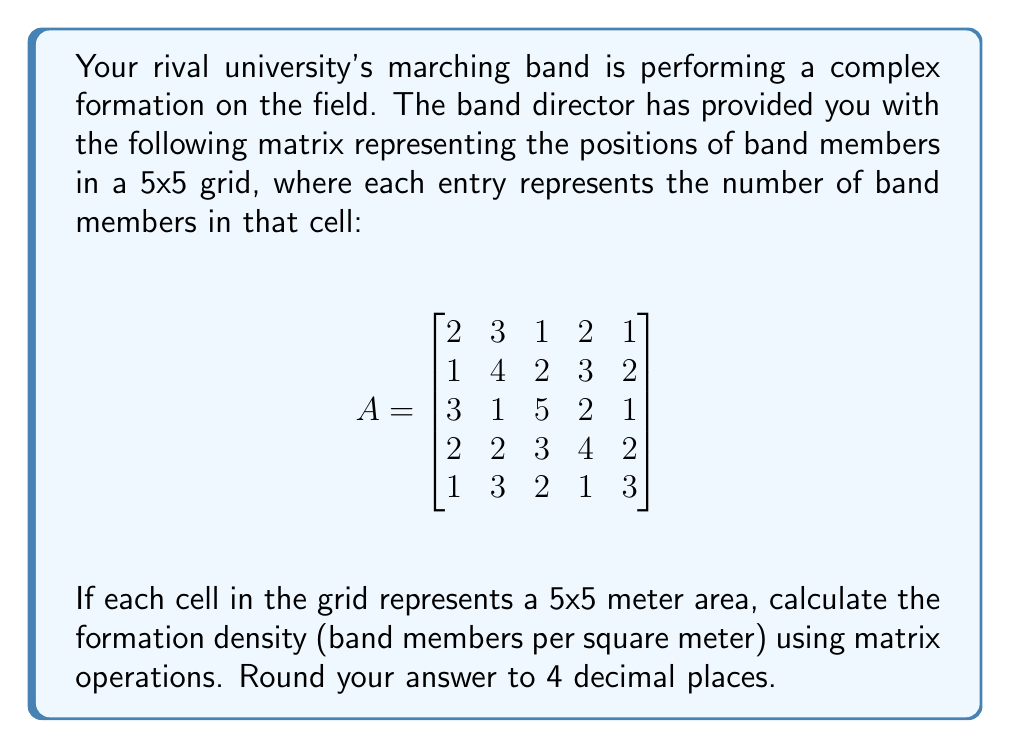Can you answer this question? To solve this problem, we'll follow these steps:

1) First, we need to calculate the total number of band members. We can do this by summing all elements in the matrix. In matrix notation, this is equivalent to multiplying the matrix by a column vector of ones and then multiplying the result by a row vector of ones:

   $$\text{Total members} = \mathbf{1}^T A \mathbf{1}$$

   Where $\mathbf{1}$ is a 5x1 column vector of ones, and $\mathbf{1}^T$ is its transpose.

2) Let's perform this calculation:

   $$\begin{bmatrix}1 & 1 & 1 & 1 & 1\end{bmatrix} \begin{bmatrix}
   2 & 3 & 1 & 2 & 1 \\
   1 & 4 & 2 & 3 & 2 \\
   3 & 1 & 5 & 2 & 1 \\
   2 & 2 & 3 & 4 & 2 \\
   1 & 3 & 2 & 1 & 3
   \end{bmatrix} \begin{bmatrix}1 \\ 1 \\ 1 \\ 1 \\ 1\end{bmatrix}$$

   $$= \begin{bmatrix}1 & 1 & 1 & 1 & 1\end{bmatrix} \begin{bmatrix}9 \\ 13 \\ 13 \\ 13 \\ 10\end{bmatrix} = 58$$

3) Now we know there are 58 band members in total.

4) Next, we need to calculate the total area. The grid is 5x5 cells, and each cell is 5x5 meters. So the total area is:

   $$\text{Total area} = 5 \times 5 \times 5 \times 5 = 625 \text{ square meters}$$

5) The formation density is the number of band members divided by the total area:

   $$\text{Density} = \frac{58}{625} = 0.0928 \text{ band members per square meter}$$

6) Rounding to 4 decimal places gives us 0.0928 band members per square meter.
Answer: 0.0928 band members/m² 